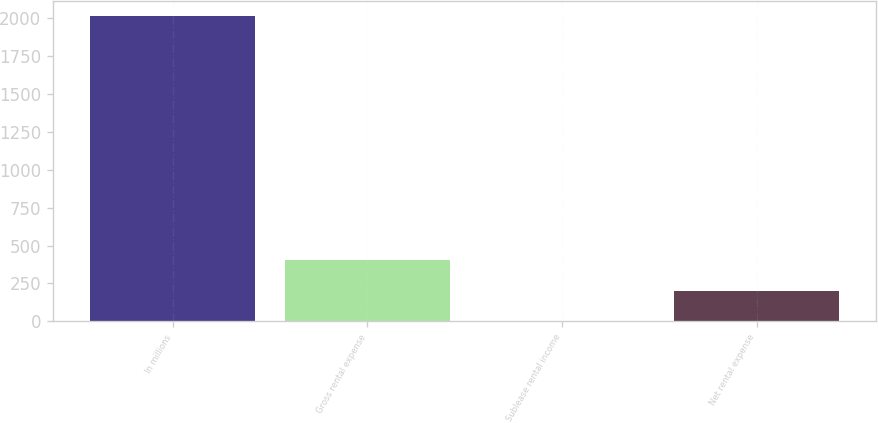Convert chart to OTSL. <chart><loc_0><loc_0><loc_500><loc_500><bar_chart><fcel>In millions<fcel>Gross rental expense<fcel>Sublease rental income<fcel>Net rental expense<nl><fcel>2016<fcel>403.76<fcel>0.7<fcel>202.23<nl></chart> 